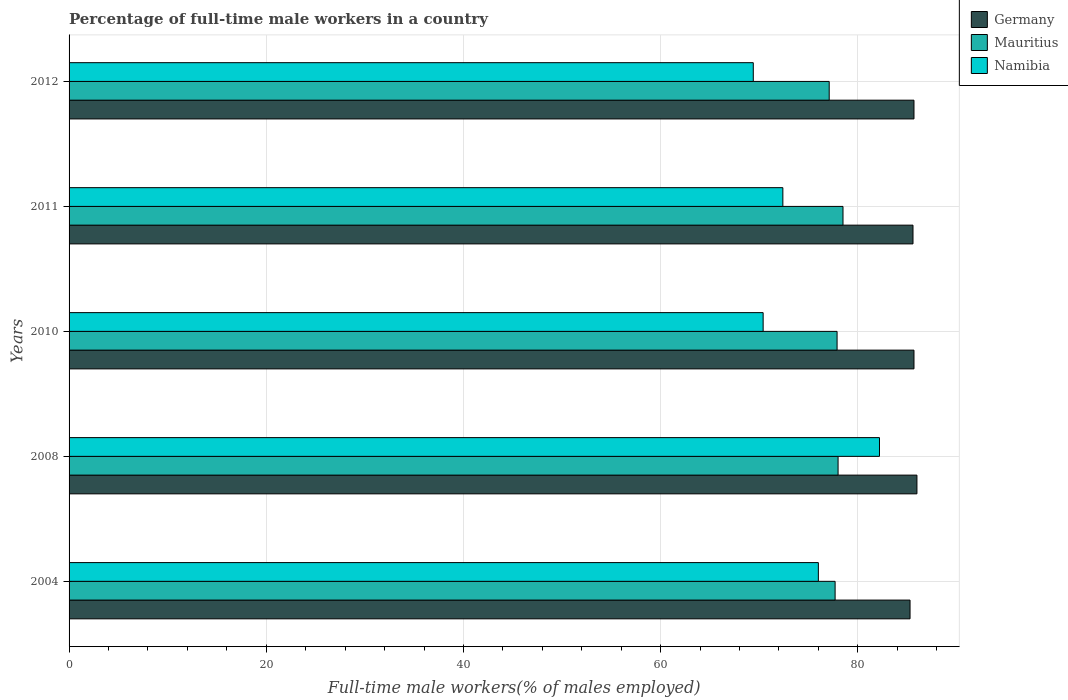How many different coloured bars are there?
Make the answer very short. 3. How many groups of bars are there?
Offer a very short reply. 5. How many bars are there on the 2nd tick from the top?
Make the answer very short. 3. What is the label of the 1st group of bars from the top?
Ensure brevity in your answer.  2012. In how many cases, is the number of bars for a given year not equal to the number of legend labels?
Make the answer very short. 0. What is the percentage of full-time male workers in Germany in 2011?
Make the answer very short. 85.6. Across all years, what is the maximum percentage of full-time male workers in Mauritius?
Keep it short and to the point. 78.5. Across all years, what is the minimum percentage of full-time male workers in Mauritius?
Your response must be concise. 77.1. What is the total percentage of full-time male workers in Germany in the graph?
Give a very brief answer. 428.3. What is the difference between the percentage of full-time male workers in Namibia in 2004 and that in 2012?
Make the answer very short. 6.6. What is the difference between the percentage of full-time male workers in Mauritius in 2010 and the percentage of full-time male workers in Namibia in 2008?
Your answer should be compact. -4.3. What is the average percentage of full-time male workers in Mauritius per year?
Your answer should be very brief. 77.84. What is the ratio of the percentage of full-time male workers in Mauritius in 2008 to that in 2011?
Your answer should be very brief. 0.99. What is the difference between the highest and the second highest percentage of full-time male workers in Namibia?
Keep it short and to the point. 6.2. What is the difference between the highest and the lowest percentage of full-time male workers in Namibia?
Provide a short and direct response. 12.8. Is the sum of the percentage of full-time male workers in Namibia in 2010 and 2012 greater than the maximum percentage of full-time male workers in Mauritius across all years?
Offer a very short reply. Yes. What does the 3rd bar from the top in 2011 represents?
Offer a very short reply. Germany. Is it the case that in every year, the sum of the percentage of full-time male workers in Namibia and percentage of full-time male workers in Mauritius is greater than the percentage of full-time male workers in Germany?
Your answer should be compact. Yes. How many bars are there?
Offer a very short reply. 15. What is the difference between two consecutive major ticks on the X-axis?
Provide a short and direct response. 20. Are the values on the major ticks of X-axis written in scientific E-notation?
Keep it short and to the point. No. Does the graph contain grids?
Your answer should be compact. Yes. How many legend labels are there?
Offer a terse response. 3. How are the legend labels stacked?
Give a very brief answer. Vertical. What is the title of the graph?
Your answer should be very brief. Percentage of full-time male workers in a country. Does "St. Lucia" appear as one of the legend labels in the graph?
Ensure brevity in your answer.  No. What is the label or title of the X-axis?
Provide a succinct answer. Full-time male workers(% of males employed). What is the label or title of the Y-axis?
Provide a succinct answer. Years. What is the Full-time male workers(% of males employed) in Germany in 2004?
Your answer should be compact. 85.3. What is the Full-time male workers(% of males employed) in Mauritius in 2004?
Offer a terse response. 77.7. What is the Full-time male workers(% of males employed) of Mauritius in 2008?
Your answer should be very brief. 78. What is the Full-time male workers(% of males employed) in Namibia in 2008?
Keep it short and to the point. 82.2. What is the Full-time male workers(% of males employed) of Germany in 2010?
Offer a very short reply. 85.7. What is the Full-time male workers(% of males employed) of Mauritius in 2010?
Your answer should be compact. 77.9. What is the Full-time male workers(% of males employed) in Namibia in 2010?
Provide a short and direct response. 70.4. What is the Full-time male workers(% of males employed) of Germany in 2011?
Provide a short and direct response. 85.6. What is the Full-time male workers(% of males employed) of Mauritius in 2011?
Make the answer very short. 78.5. What is the Full-time male workers(% of males employed) of Namibia in 2011?
Provide a short and direct response. 72.4. What is the Full-time male workers(% of males employed) in Germany in 2012?
Your answer should be very brief. 85.7. What is the Full-time male workers(% of males employed) in Mauritius in 2012?
Your answer should be very brief. 77.1. What is the Full-time male workers(% of males employed) in Namibia in 2012?
Ensure brevity in your answer.  69.4. Across all years, what is the maximum Full-time male workers(% of males employed) of Mauritius?
Ensure brevity in your answer.  78.5. Across all years, what is the maximum Full-time male workers(% of males employed) of Namibia?
Your answer should be compact. 82.2. Across all years, what is the minimum Full-time male workers(% of males employed) of Germany?
Ensure brevity in your answer.  85.3. Across all years, what is the minimum Full-time male workers(% of males employed) in Mauritius?
Make the answer very short. 77.1. Across all years, what is the minimum Full-time male workers(% of males employed) of Namibia?
Ensure brevity in your answer.  69.4. What is the total Full-time male workers(% of males employed) in Germany in the graph?
Your response must be concise. 428.3. What is the total Full-time male workers(% of males employed) in Mauritius in the graph?
Offer a very short reply. 389.2. What is the total Full-time male workers(% of males employed) of Namibia in the graph?
Your answer should be compact. 370.4. What is the difference between the Full-time male workers(% of males employed) in Germany in 2004 and that in 2008?
Offer a terse response. -0.7. What is the difference between the Full-time male workers(% of males employed) of Mauritius in 2004 and that in 2010?
Ensure brevity in your answer.  -0.2. What is the difference between the Full-time male workers(% of males employed) of Namibia in 2004 and that in 2010?
Offer a very short reply. 5.6. What is the difference between the Full-time male workers(% of males employed) of Germany in 2004 and that in 2011?
Your answer should be very brief. -0.3. What is the difference between the Full-time male workers(% of males employed) of Namibia in 2004 and that in 2011?
Ensure brevity in your answer.  3.6. What is the difference between the Full-time male workers(% of males employed) of Germany in 2004 and that in 2012?
Your answer should be very brief. -0.4. What is the difference between the Full-time male workers(% of males employed) of Mauritius in 2004 and that in 2012?
Offer a very short reply. 0.6. What is the difference between the Full-time male workers(% of males employed) in Namibia in 2004 and that in 2012?
Offer a very short reply. 6.6. What is the difference between the Full-time male workers(% of males employed) of Mauritius in 2008 and that in 2010?
Your response must be concise. 0.1. What is the difference between the Full-time male workers(% of males employed) in Germany in 2008 and that in 2011?
Ensure brevity in your answer.  0.4. What is the difference between the Full-time male workers(% of males employed) in Mauritius in 2008 and that in 2011?
Provide a short and direct response. -0.5. What is the difference between the Full-time male workers(% of males employed) in Namibia in 2008 and that in 2011?
Provide a short and direct response. 9.8. What is the difference between the Full-time male workers(% of males employed) in Germany in 2008 and that in 2012?
Your response must be concise. 0.3. What is the difference between the Full-time male workers(% of males employed) in Mauritius in 2008 and that in 2012?
Your answer should be compact. 0.9. What is the difference between the Full-time male workers(% of males employed) in Namibia in 2008 and that in 2012?
Keep it short and to the point. 12.8. What is the difference between the Full-time male workers(% of males employed) of Germany in 2010 and that in 2011?
Give a very brief answer. 0.1. What is the difference between the Full-time male workers(% of males employed) of Mauritius in 2010 and that in 2012?
Offer a terse response. 0.8. What is the difference between the Full-time male workers(% of males employed) of Mauritius in 2011 and that in 2012?
Offer a terse response. 1.4. What is the difference between the Full-time male workers(% of males employed) of Namibia in 2011 and that in 2012?
Make the answer very short. 3. What is the difference between the Full-time male workers(% of males employed) in Germany in 2004 and the Full-time male workers(% of males employed) in Namibia in 2008?
Provide a short and direct response. 3.1. What is the difference between the Full-time male workers(% of males employed) of Germany in 2004 and the Full-time male workers(% of males employed) of Namibia in 2010?
Ensure brevity in your answer.  14.9. What is the difference between the Full-time male workers(% of males employed) in Germany in 2004 and the Full-time male workers(% of males employed) in Namibia in 2011?
Provide a succinct answer. 12.9. What is the difference between the Full-time male workers(% of males employed) in Mauritius in 2008 and the Full-time male workers(% of males employed) in Namibia in 2010?
Make the answer very short. 7.6. What is the difference between the Full-time male workers(% of males employed) in Germany in 2008 and the Full-time male workers(% of males employed) in Namibia in 2011?
Make the answer very short. 13.6. What is the difference between the Full-time male workers(% of males employed) of Germany in 2008 and the Full-time male workers(% of males employed) of Mauritius in 2012?
Your response must be concise. 8.9. What is the difference between the Full-time male workers(% of males employed) of Mauritius in 2008 and the Full-time male workers(% of males employed) of Namibia in 2012?
Make the answer very short. 8.6. What is the difference between the Full-time male workers(% of males employed) in Mauritius in 2010 and the Full-time male workers(% of males employed) in Namibia in 2011?
Your answer should be very brief. 5.5. What is the difference between the Full-time male workers(% of males employed) in Germany in 2010 and the Full-time male workers(% of males employed) in Mauritius in 2012?
Give a very brief answer. 8.6. What is the difference between the Full-time male workers(% of males employed) of Germany in 2010 and the Full-time male workers(% of males employed) of Namibia in 2012?
Offer a terse response. 16.3. What is the difference between the Full-time male workers(% of males employed) in Mauritius in 2010 and the Full-time male workers(% of males employed) in Namibia in 2012?
Your response must be concise. 8.5. What is the difference between the Full-time male workers(% of males employed) of Germany in 2011 and the Full-time male workers(% of males employed) of Mauritius in 2012?
Your response must be concise. 8.5. What is the average Full-time male workers(% of males employed) of Germany per year?
Your response must be concise. 85.66. What is the average Full-time male workers(% of males employed) in Mauritius per year?
Make the answer very short. 77.84. What is the average Full-time male workers(% of males employed) in Namibia per year?
Keep it short and to the point. 74.08. In the year 2004, what is the difference between the Full-time male workers(% of males employed) of Germany and Full-time male workers(% of males employed) of Mauritius?
Provide a succinct answer. 7.6. In the year 2004, what is the difference between the Full-time male workers(% of males employed) of Germany and Full-time male workers(% of males employed) of Namibia?
Ensure brevity in your answer.  9.3. In the year 2008, what is the difference between the Full-time male workers(% of males employed) of Germany and Full-time male workers(% of males employed) of Namibia?
Provide a succinct answer. 3.8. In the year 2008, what is the difference between the Full-time male workers(% of males employed) in Mauritius and Full-time male workers(% of males employed) in Namibia?
Keep it short and to the point. -4.2. In the year 2011, what is the difference between the Full-time male workers(% of males employed) in Germany and Full-time male workers(% of males employed) in Mauritius?
Make the answer very short. 7.1. What is the ratio of the Full-time male workers(% of males employed) in Namibia in 2004 to that in 2008?
Your answer should be very brief. 0.92. What is the ratio of the Full-time male workers(% of males employed) in Namibia in 2004 to that in 2010?
Provide a short and direct response. 1.08. What is the ratio of the Full-time male workers(% of males employed) of Mauritius in 2004 to that in 2011?
Provide a short and direct response. 0.99. What is the ratio of the Full-time male workers(% of males employed) of Namibia in 2004 to that in 2011?
Provide a succinct answer. 1.05. What is the ratio of the Full-time male workers(% of males employed) of Germany in 2004 to that in 2012?
Give a very brief answer. 1. What is the ratio of the Full-time male workers(% of males employed) in Namibia in 2004 to that in 2012?
Provide a succinct answer. 1.1. What is the ratio of the Full-time male workers(% of males employed) of Mauritius in 2008 to that in 2010?
Offer a terse response. 1. What is the ratio of the Full-time male workers(% of males employed) in Namibia in 2008 to that in 2010?
Your answer should be very brief. 1.17. What is the ratio of the Full-time male workers(% of males employed) of Germany in 2008 to that in 2011?
Your response must be concise. 1. What is the ratio of the Full-time male workers(% of males employed) of Mauritius in 2008 to that in 2011?
Ensure brevity in your answer.  0.99. What is the ratio of the Full-time male workers(% of males employed) of Namibia in 2008 to that in 2011?
Your answer should be very brief. 1.14. What is the ratio of the Full-time male workers(% of males employed) of Mauritius in 2008 to that in 2012?
Your response must be concise. 1.01. What is the ratio of the Full-time male workers(% of males employed) in Namibia in 2008 to that in 2012?
Provide a short and direct response. 1.18. What is the ratio of the Full-time male workers(% of males employed) of Germany in 2010 to that in 2011?
Your answer should be very brief. 1. What is the ratio of the Full-time male workers(% of males employed) of Mauritius in 2010 to that in 2011?
Offer a very short reply. 0.99. What is the ratio of the Full-time male workers(% of males employed) in Namibia in 2010 to that in 2011?
Your response must be concise. 0.97. What is the ratio of the Full-time male workers(% of males employed) of Mauritius in 2010 to that in 2012?
Give a very brief answer. 1.01. What is the ratio of the Full-time male workers(% of males employed) in Namibia in 2010 to that in 2012?
Your response must be concise. 1.01. What is the ratio of the Full-time male workers(% of males employed) of Mauritius in 2011 to that in 2012?
Provide a succinct answer. 1.02. What is the ratio of the Full-time male workers(% of males employed) of Namibia in 2011 to that in 2012?
Your answer should be very brief. 1.04. What is the difference between the highest and the second highest Full-time male workers(% of males employed) of Germany?
Your answer should be compact. 0.3. What is the difference between the highest and the second highest Full-time male workers(% of males employed) of Namibia?
Give a very brief answer. 6.2. What is the difference between the highest and the lowest Full-time male workers(% of males employed) in Germany?
Your answer should be very brief. 0.7. What is the difference between the highest and the lowest Full-time male workers(% of males employed) in Namibia?
Ensure brevity in your answer.  12.8. 